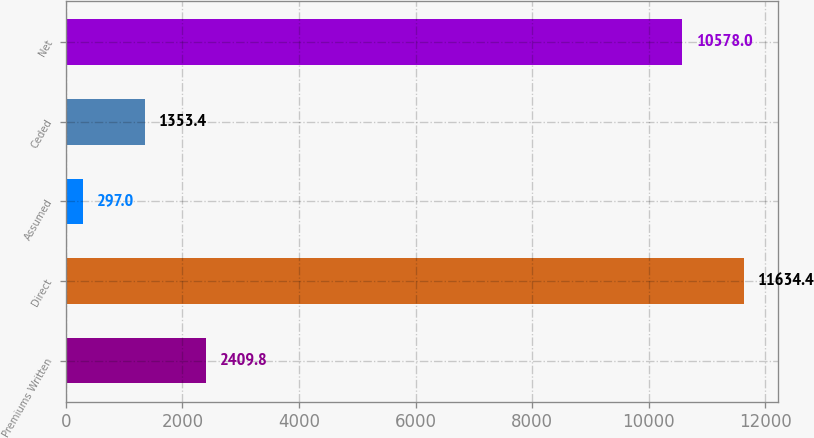Convert chart. <chart><loc_0><loc_0><loc_500><loc_500><bar_chart><fcel>Premiums Written<fcel>Direct<fcel>Assumed<fcel>Ceded<fcel>Net<nl><fcel>2409.8<fcel>11634.4<fcel>297<fcel>1353.4<fcel>10578<nl></chart> 